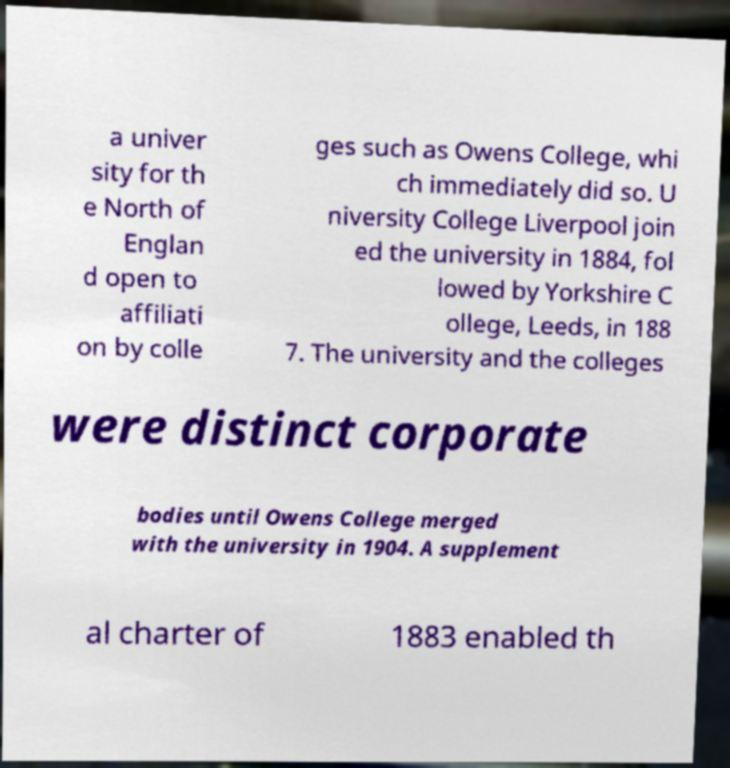For documentation purposes, I need the text within this image transcribed. Could you provide that? a univer sity for th e North of Englan d open to affiliati on by colle ges such as Owens College, whi ch immediately did so. U niversity College Liverpool join ed the university in 1884, fol lowed by Yorkshire C ollege, Leeds, in 188 7. The university and the colleges were distinct corporate bodies until Owens College merged with the university in 1904. A supplement al charter of 1883 enabled th 